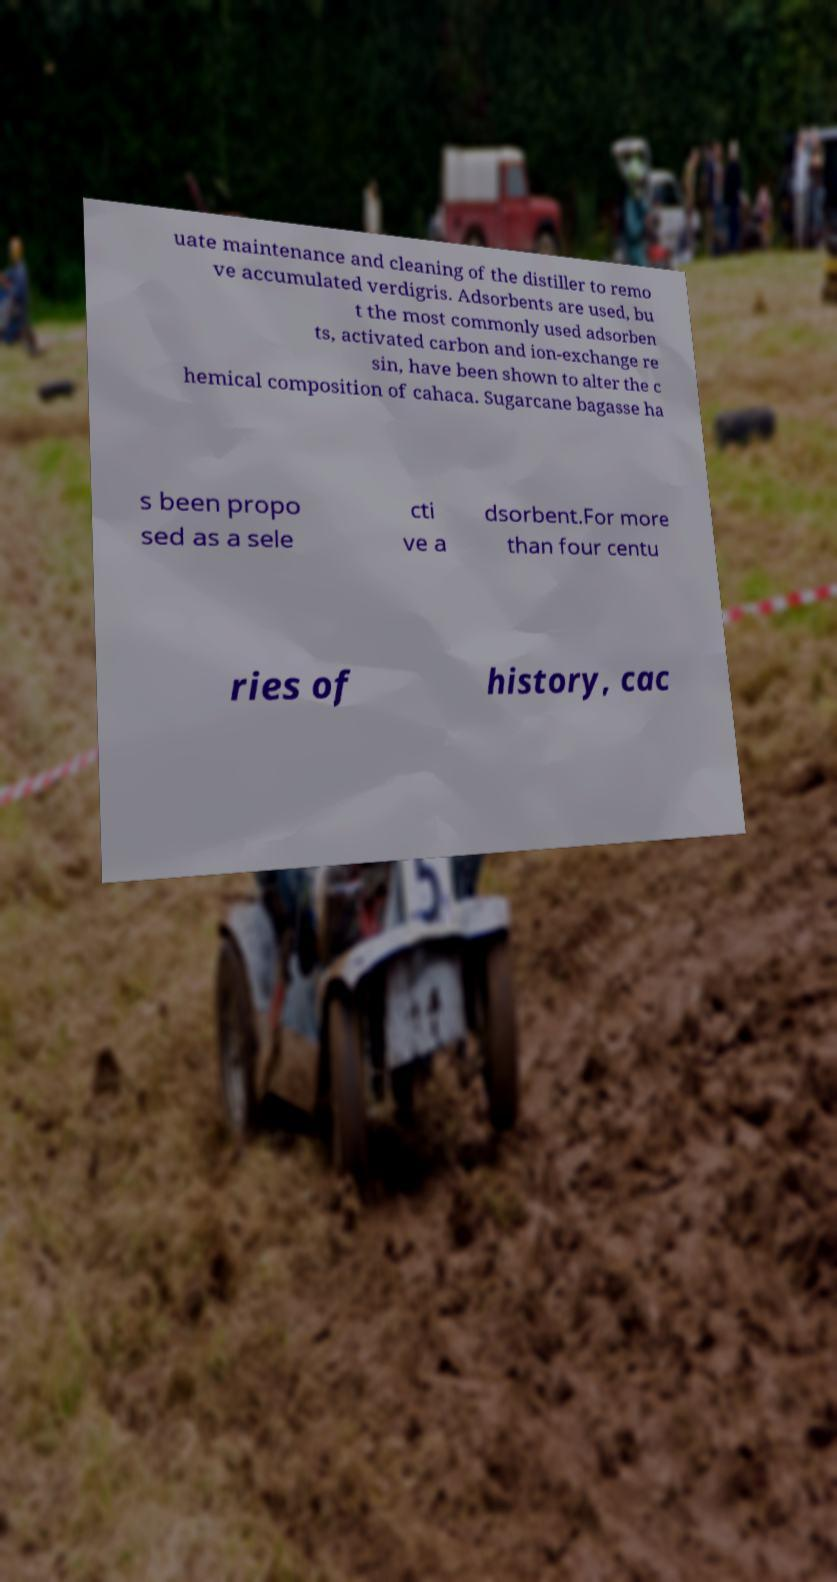Please identify and transcribe the text found in this image. uate maintenance and cleaning of the distiller to remo ve accumulated verdigris. Adsorbents are used, bu t the most commonly used adsorben ts, activated carbon and ion-exchange re sin, have been shown to alter the c hemical composition of cahaca. Sugarcane bagasse ha s been propo sed as a sele cti ve a dsorbent.For more than four centu ries of history, cac 